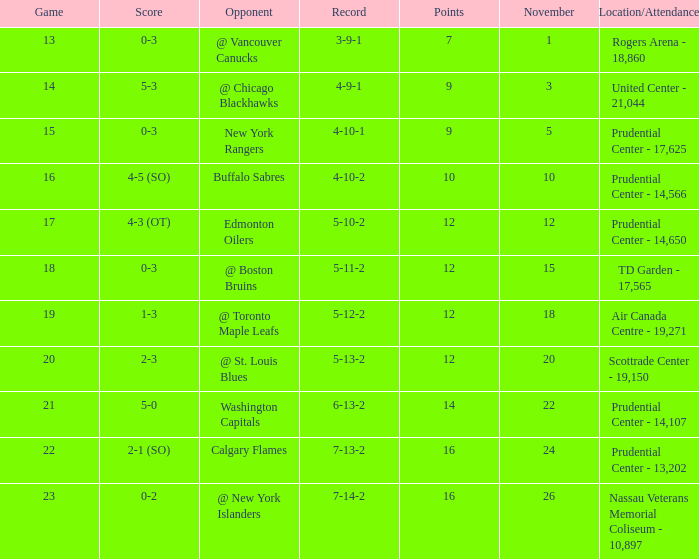What is the total number of locations that had a score of 1-3? 1.0. 